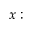Convert formula to latex. <formula><loc_0><loc_0><loc_500><loc_500>x \colon</formula> 